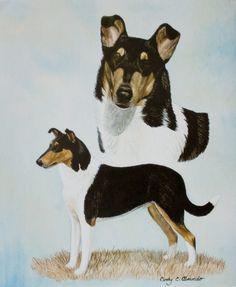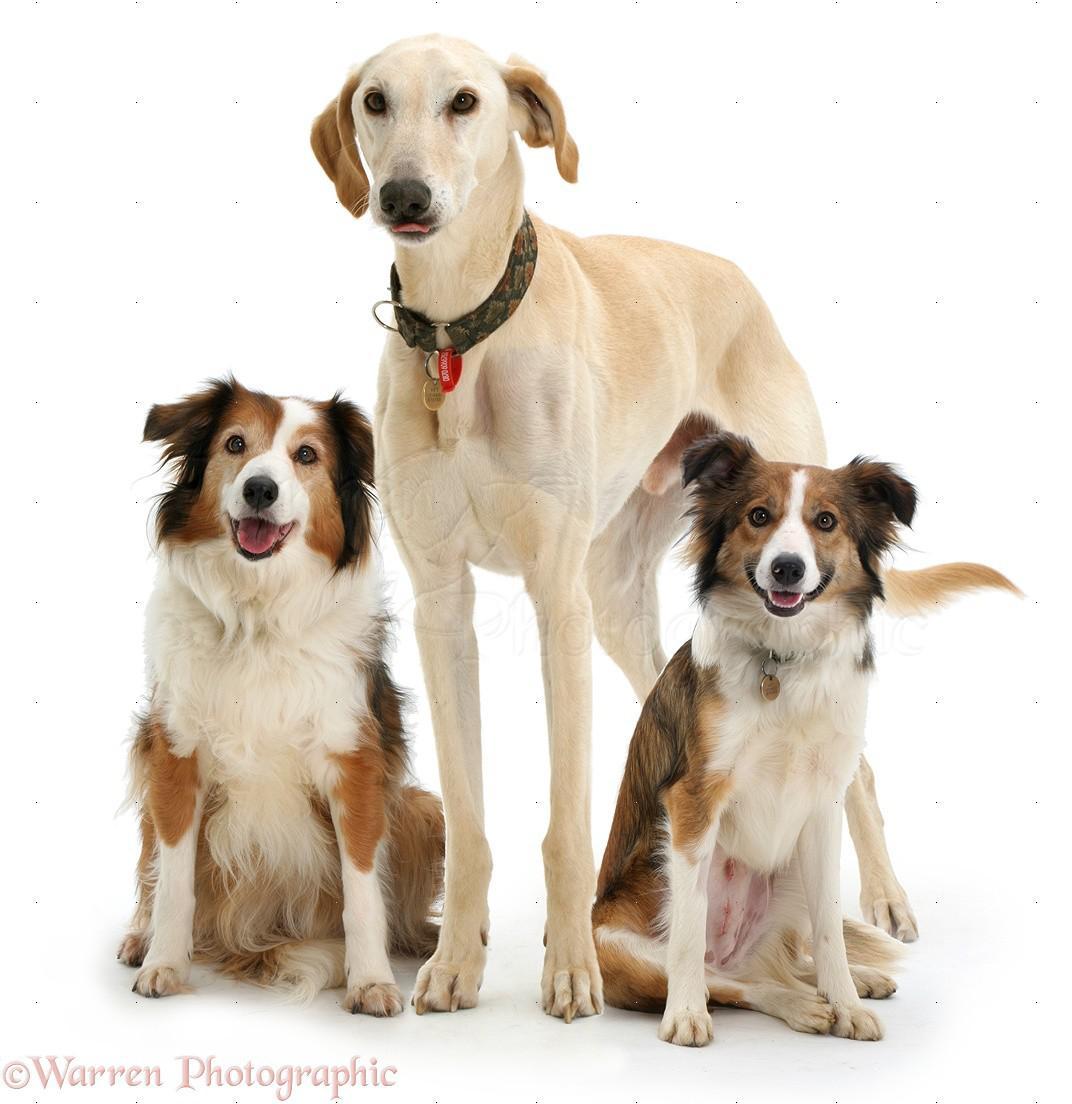The first image is the image on the left, the second image is the image on the right. Evaluate the accuracy of this statement regarding the images: "At least one of the dogs is standing up in the image on the right.". Is it true? Answer yes or no. Yes. The first image is the image on the left, the second image is the image on the right. Assess this claim about the two images: "There are at most four dogs.". Correct or not? Answer yes or no. No. 